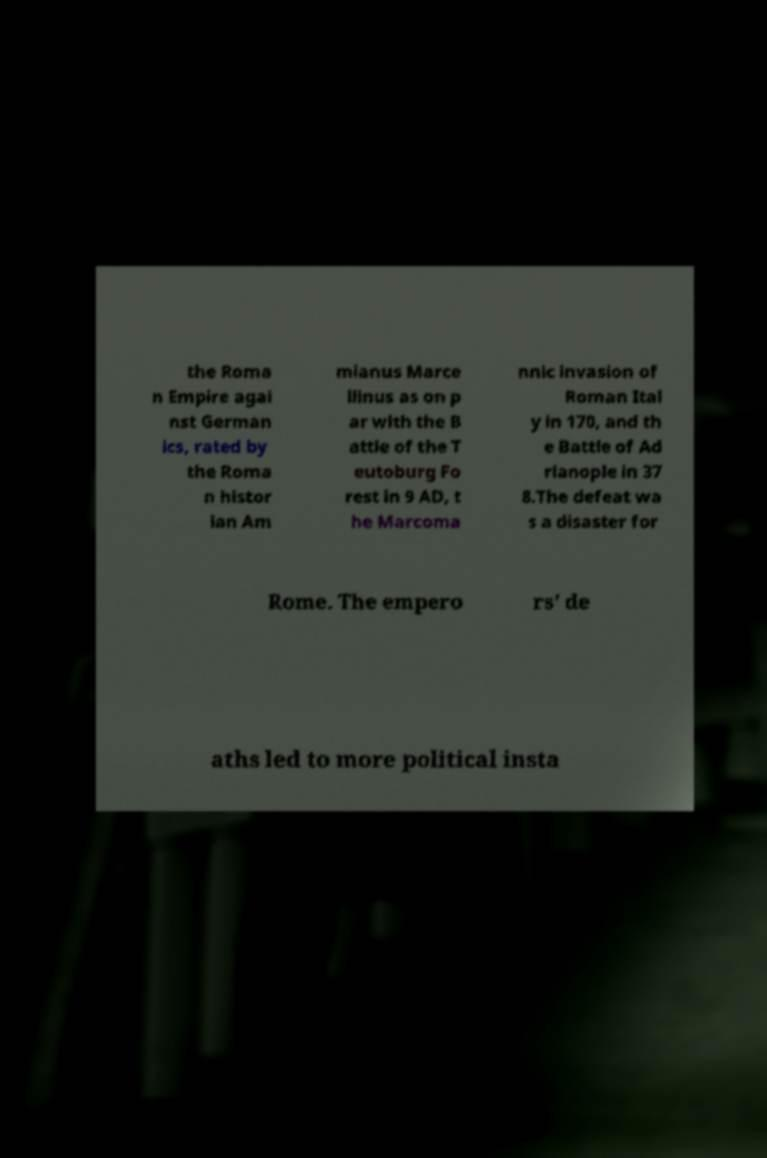Could you extract and type out the text from this image? the Roma n Empire agai nst German ics, rated by the Roma n histor ian Am mianus Marce llinus as on p ar with the B attle of the T eutoburg Fo rest in 9 AD, t he Marcoma nnic invasion of Roman Ital y in 170, and th e Battle of Ad rianople in 37 8.The defeat wa s a disaster for Rome. The empero rs' de aths led to more political insta 